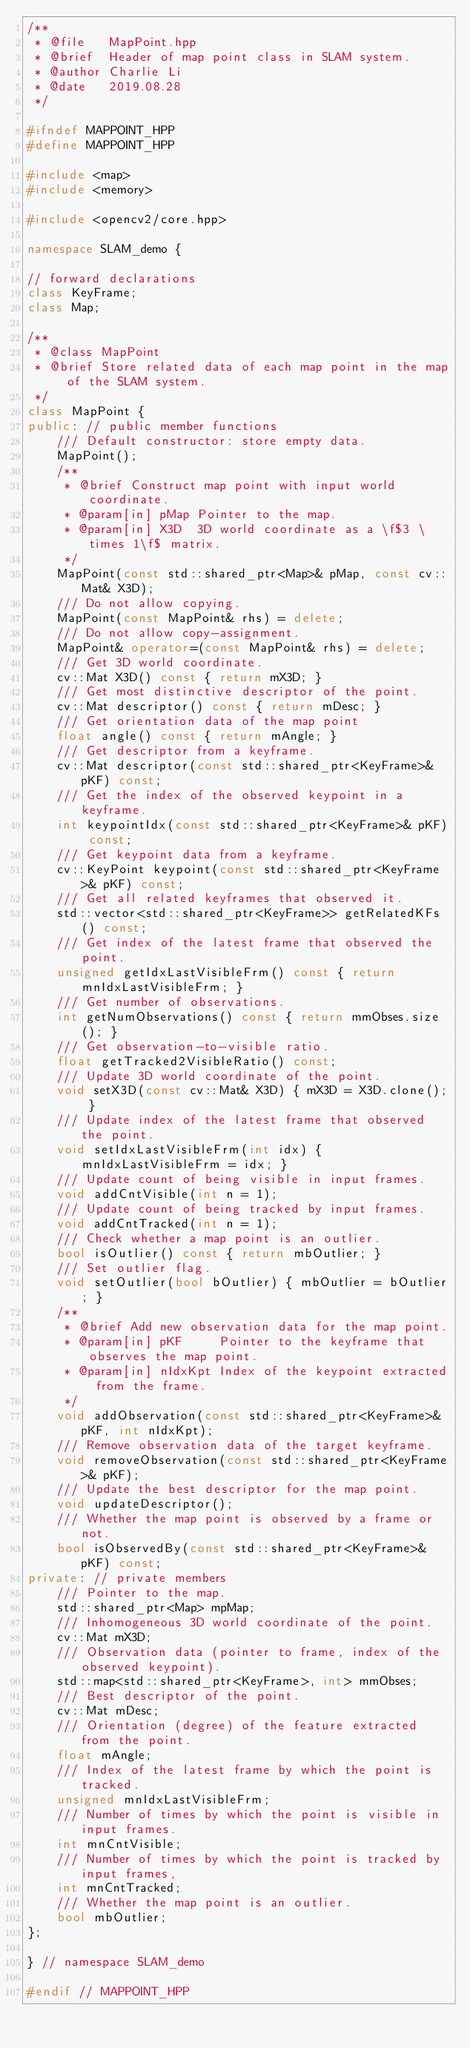<code> <loc_0><loc_0><loc_500><loc_500><_C++_>/**
 * @file   MapPoint.hpp
 * @brief  Header of map point class in SLAM system.
 * @author Charlie Li
 * @date   2019.08.28
 */

#ifndef MAPPOINT_HPP
#define MAPPOINT_HPP

#include <map>
#include <memory>

#include <opencv2/core.hpp>

namespace SLAM_demo {

// forward declarations
class KeyFrame;
class Map;

/**
 * @class MapPoint
 * @brief Store related data of each map point in the map of the SLAM system.
 */
class MapPoint {
public: // public member functions
    /// Default constructor: store empty data.
    MapPoint();
    /**
     * @brief Construct map point with input world coordinate.
     * @param[in] pMap Pointer to the map.
     * @param[in] X3D  3D world coordinate as a \f$3 \times 1\f$ matrix.
     */
    MapPoint(const std::shared_ptr<Map>& pMap, const cv::Mat& X3D);
    /// Do not allow copying.
    MapPoint(const MapPoint& rhs) = delete;
    /// Do not allow copy-assignment.
    MapPoint& operator=(const MapPoint& rhs) = delete;
    /// Get 3D world coordinate.
    cv::Mat X3D() const { return mX3D; }
    /// Get most distinctive descriptor of the point.
    cv::Mat descriptor() const { return mDesc; }
    /// Get orientation data of the map point
    float angle() const { return mAngle; }
    /// Get descriptor from a keyframe.
    cv::Mat descriptor(const std::shared_ptr<KeyFrame>& pKF) const;
    /// Get the index of the observed keypoint in a keyframe.
    int keypointIdx(const std::shared_ptr<KeyFrame>& pKF) const;
    /// Get keypoint data from a keyframe.
    cv::KeyPoint keypoint(const std::shared_ptr<KeyFrame>& pKF) const;
    /// Get all related keyframes that observed it.
    std::vector<std::shared_ptr<KeyFrame>> getRelatedKFs() const;
    /// Get index of the latest frame that observed the point.
    unsigned getIdxLastVisibleFrm() const { return mnIdxLastVisibleFrm; }
    /// Get number of observations.
    int getNumObservations() const { return mmObses.size(); }
    /// Get observation-to-visible ratio.
    float getTracked2VisibleRatio() const;
    /// Update 3D world coordinate of the point.
    void setX3D(const cv::Mat& X3D) { mX3D = X3D.clone(); }
    /// Update index of the latest frame that observed the point.
    void setIdxLastVisibleFrm(int idx) { mnIdxLastVisibleFrm = idx; }
    /// Update count of being visible in input frames.
    void addCntVisible(int n = 1);
    /// Update count of being tracked by input frames.
    void addCntTracked(int n = 1);
    /// Check whether a map point is an outlier.
    bool isOutlier() const { return mbOutlier; }
    /// Set outlier flag.
    void setOutlier(bool bOutlier) { mbOutlier = bOutlier; }
    /**
     * @brief Add new observation data for the map point.
     * @param[in] pKF     Pointer to the keyframe that observes the map point.
     * @param[in] nIdxKpt Index of the keypoint extracted from the frame.
     */
    void addObservation(const std::shared_ptr<KeyFrame>& pKF, int nIdxKpt);
    /// Remove observation data of the target keyframe.
    void removeObservation(const std::shared_ptr<KeyFrame>& pKF);
    /// Update the best descriptor for the map point.
    void updateDescriptor();
    /// Whether the map point is observed by a frame or not.
    bool isObservedBy(const std::shared_ptr<KeyFrame>& pKF) const;
private: // private members
    /// Pointer to the map.
    std::shared_ptr<Map> mpMap;
    /// Inhomogeneous 3D world coordinate of the point.
    cv::Mat mX3D;
    /// Observation data (pointer to frame, index of the observed keypoint).
    std::map<std::shared_ptr<KeyFrame>, int> mmObses;
    /// Best descriptor of the point.
    cv::Mat mDesc;
    /// Orientation (degree) of the feature extracted from the point.
    float mAngle;
    /// Index of the latest frame by which the point is tracked.
    unsigned mnIdxLastVisibleFrm;
    /// Number of times by which the point is visible in input frames.
    int mnCntVisible;
    /// Number of times by which the point is tracked by input frames,
    int mnCntTracked;
    /// Whether the map point is an outlier.
    bool mbOutlier;
};

} // namespace SLAM_demo

#endif // MAPPOINT_HPP
</code> 